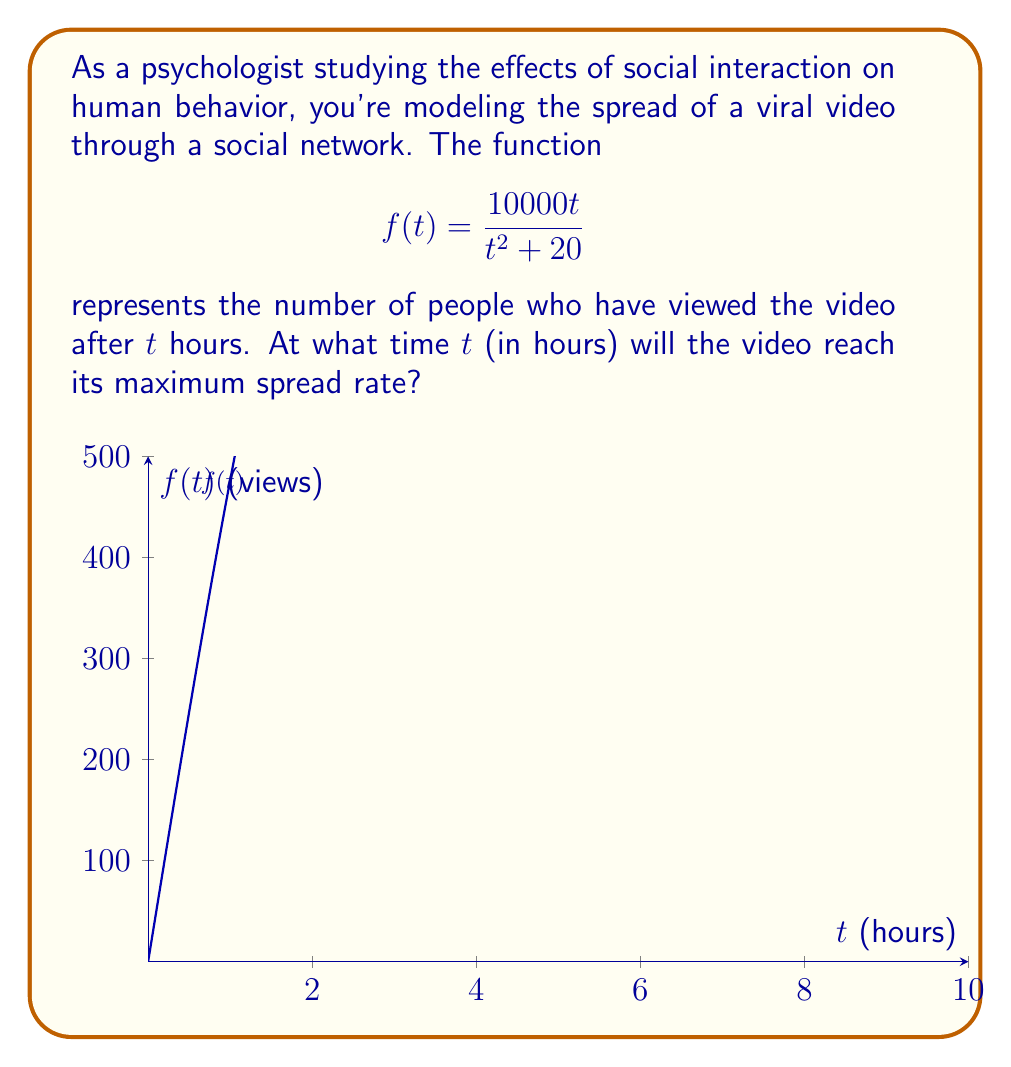Can you answer this question? To find the time of maximum spread rate, we need to find the maximum of the derivative of $f(t)$. Let's approach this step-by-step:

1) First, let's find the derivative of $f(t)$ using the quotient rule:

   $$f'(t) = \frac{(t^2 + 20)(10000) - 10000t(2t)}{(t^2 + 20)^2}$$

2) Simplify:

   $$f'(t) = \frac{10000(t^2 + 20) - 20000t^2}{(t^2 + 20)^2} = \frac{10000(20 - t^2)}{(t^2 + 20)^2}$$

3) To find the maximum of $f'(t)$, we need to find where its derivative equals zero:

   $$f''(t) = \frac{-20000t(t^2 + 20)^2 - 2(10000)(20 - t^2)(t^2 + 20)(2t)}{(t^2 + 20)^4} = 0$$

4) The numerator must equal zero (the denominator is always positive):

   $$-20000t(t^2 + 20)^2 - 40000(20 - t^2)(t^2 + 20)t = 0$$

5) Factor out $20000t$:

   $$20000t[-(t^2 + 20)^2 - 2(20 - t^2)(t^2 + 20)] = 0$$

6) Either $t = 0$ or the expression in brackets equals zero. $t = 0$ gives a minimum, not a maximum, so we focus on the bracket:

   $$-(t^2 + 20)^2 - 2(20 - t^2)(t^2 + 20) = 0$$

7) Expand:

   $$-(t^4 + 40t^2 + 400) - 2(20t^2 + 400 - t^4 - 20t^2) = 0$$
   $$-t^4 - 40t^2 - 400 - 40t^2 - 800 + 2t^4 + 40t^2 = 0$$
   $$t^4 - 40t^2 - 1200 = 0$$

8) This is a quadratic in $t^2$. Let $u = t^2$:

   $$u^2 - 40u - 1200 = 0$$

9) Solve using the quadratic formula:

   $$u = \frac{40 \pm \sqrt{1600 + 4800}}{2} = \frac{40 \pm \sqrt{6400}}{2} = \frac{40 \pm 80}{2}$$

10) We want the positive solution:

    $$u = \frac{40 + 80}{2} = 60$$

11) Remember $u = t^2$, so:

    $$t^2 = 60$$
    $$t = \sqrt{60} \approx 7.746$$

Therefore, the video reaches its maximum spread rate after approximately 7.746 hours.
Answer: $\sqrt{60}$ hours 